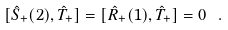<formula> <loc_0><loc_0><loc_500><loc_500>[ { \hat { S } } _ { + } ( 2 ) , { \hat { T } } _ { + } ] = [ { \hat { R } } _ { + } ( 1 ) , { \hat { T } } _ { + } ] = 0 \ .</formula> 